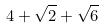<formula> <loc_0><loc_0><loc_500><loc_500>4 + \sqrt { 2 } + \sqrt { 6 }</formula> 